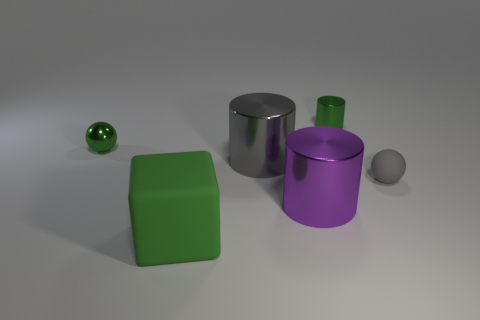Add 2 big red cubes. How many objects exist? 8 Subtract all blocks. How many objects are left? 5 Subtract all tiny gray spheres. Subtract all rubber blocks. How many objects are left? 4 Add 2 gray things. How many gray things are left? 4 Add 5 large gray metal cylinders. How many large gray metal cylinders exist? 6 Subtract 0 blue balls. How many objects are left? 6 